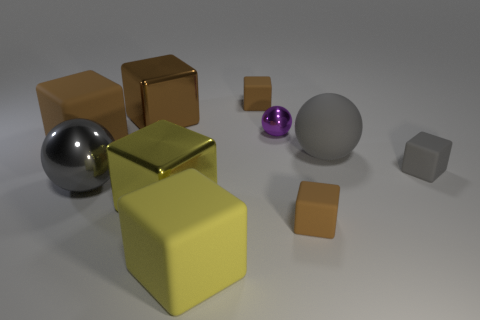What material is the ball behind the cube on the left side of the big sphere that is in front of the tiny gray cube made of?
Offer a very short reply. Metal. What material is the small cube that is the same color as the matte sphere?
Make the answer very short. Rubber. How many objects have the same material as the gray cube?
Offer a very short reply. 5. Does the shiny cube that is in front of the gray rubber cube have the same size as the big gray rubber sphere?
Make the answer very short. Yes. There is another ball that is made of the same material as the tiny ball; what color is it?
Make the answer very short. Gray. Is there anything else that is the same size as the yellow rubber cube?
Ensure brevity in your answer.  Yes. How many tiny brown objects are in front of the gray metallic thing?
Keep it short and to the point. 1. There is a matte block to the left of the big brown metallic block; is its color the same as the small block in front of the gray metallic ball?
Keep it short and to the point. Yes. The other big metal thing that is the same shape as the big yellow shiny object is what color?
Your answer should be compact. Brown. Is there anything else that is the same shape as the large gray metal thing?
Your answer should be compact. Yes. 